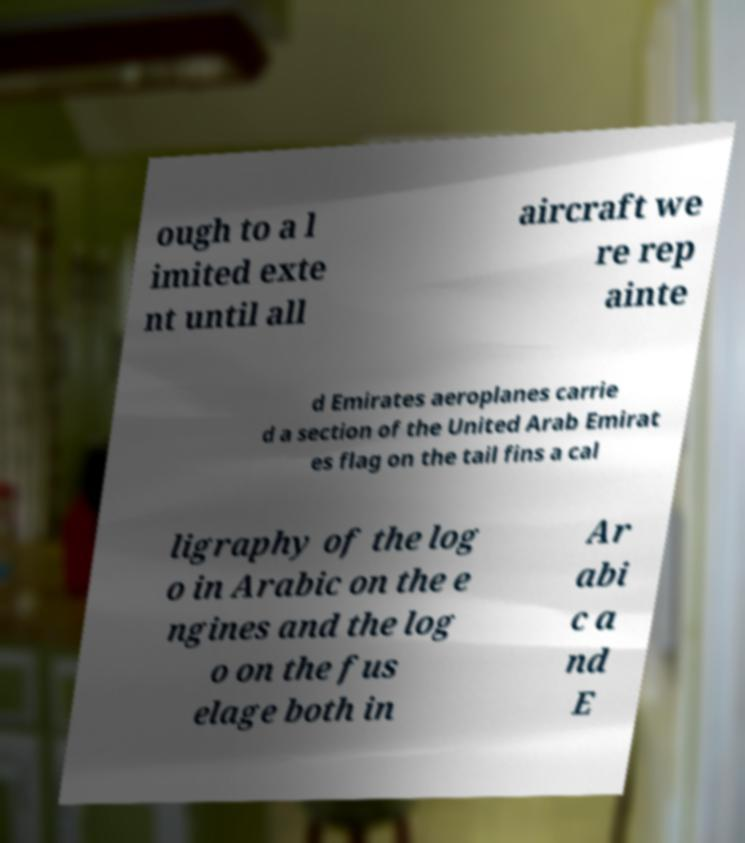For documentation purposes, I need the text within this image transcribed. Could you provide that? ough to a l imited exte nt until all aircraft we re rep ainte d Emirates aeroplanes carrie d a section of the United Arab Emirat es flag on the tail fins a cal ligraphy of the log o in Arabic on the e ngines and the log o on the fus elage both in Ar abi c a nd E 